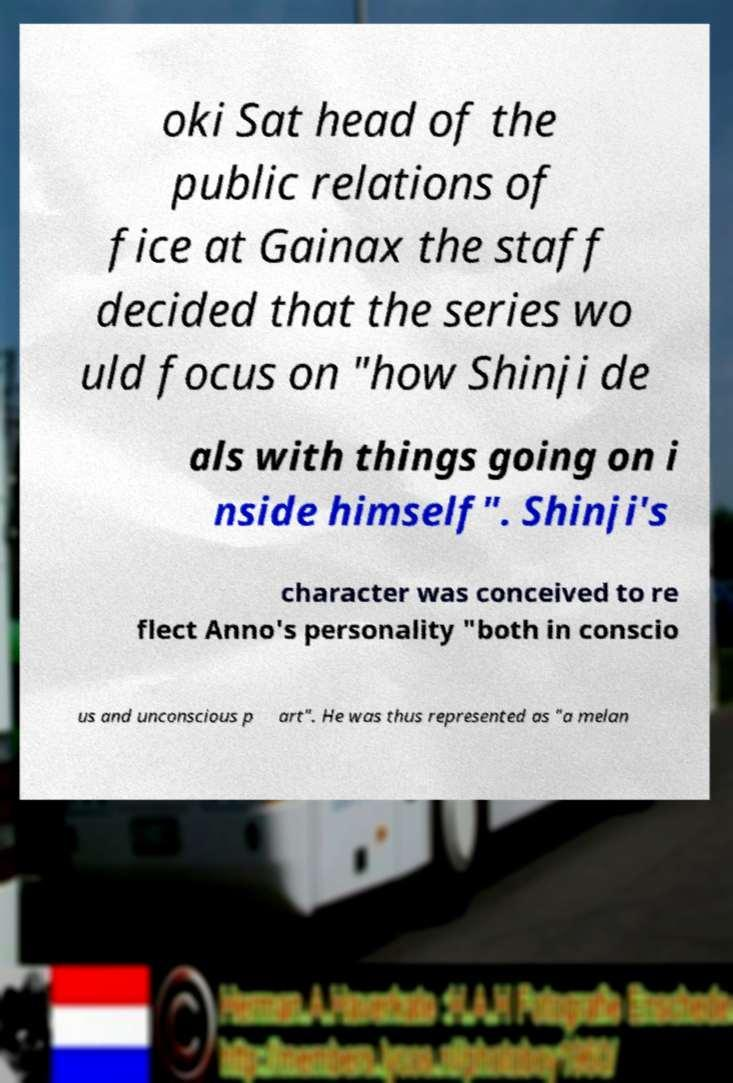Could you extract and type out the text from this image? oki Sat head of the public relations of fice at Gainax the staff decided that the series wo uld focus on "how Shinji de als with things going on i nside himself". Shinji's character was conceived to re flect Anno's personality "both in conscio us and unconscious p art". He was thus represented as "a melan 